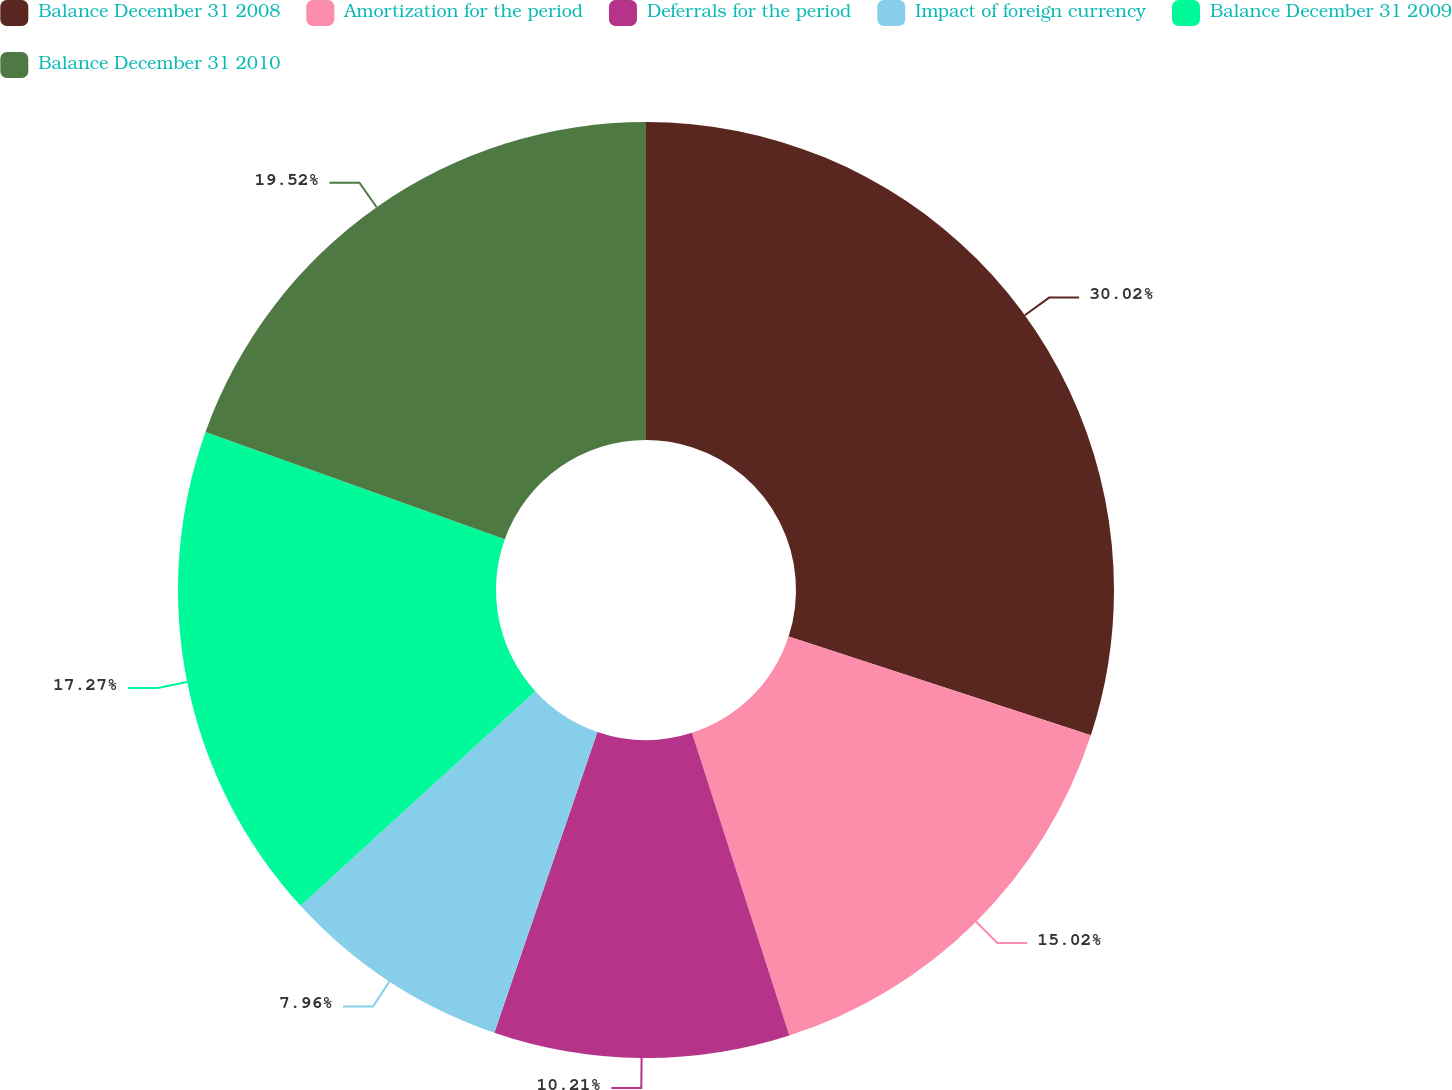Convert chart to OTSL. <chart><loc_0><loc_0><loc_500><loc_500><pie_chart><fcel>Balance December 31 2008<fcel>Amortization for the period<fcel>Deferrals for the period<fcel>Impact of foreign currency<fcel>Balance December 31 2009<fcel>Balance December 31 2010<nl><fcel>30.03%<fcel>15.02%<fcel>10.21%<fcel>7.96%<fcel>17.27%<fcel>19.52%<nl></chart> 